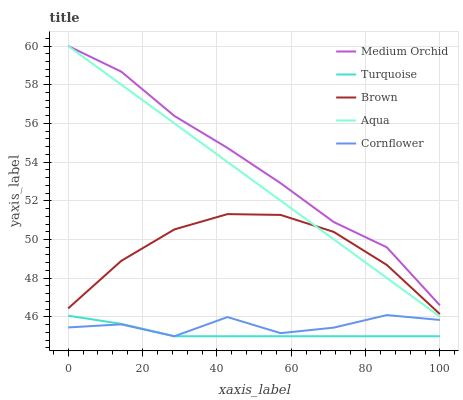Does Turquoise have the minimum area under the curve?
Answer yes or no. Yes. Does Medium Orchid have the maximum area under the curve?
Answer yes or no. Yes. Does Medium Orchid have the minimum area under the curve?
Answer yes or no. No. Does Turquoise have the maximum area under the curve?
Answer yes or no. No. Is Aqua the smoothest?
Answer yes or no. Yes. Is Cornflower the roughest?
Answer yes or no. Yes. Is Turquoise the smoothest?
Answer yes or no. No. Is Turquoise the roughest?
Answer yes or no. No. Does Turquoise have the lowest value?
Answer yes or no. Yes. Does Medium Orchid have the lowest value?
Answer yes or no. No. Does Aqua have the highest value?
Answer yes or no. Yes. Does Turquoise have the highest value?
Answer yes or no. No. Is Cornflower less than Aqua?
Answer yes or no. Yes. Is Brown greater than Turquoise?
Answer yes or no. Yes. Does Aqua intersect Brown?
Answer yes or no. Yes. Is Aqua less than Brown?
Answer yes or no. No. Is Aqua greater than Brown?
Answer yes or no. No. Does Cornflower intersect Aqua?
Answer yes or no. No. 